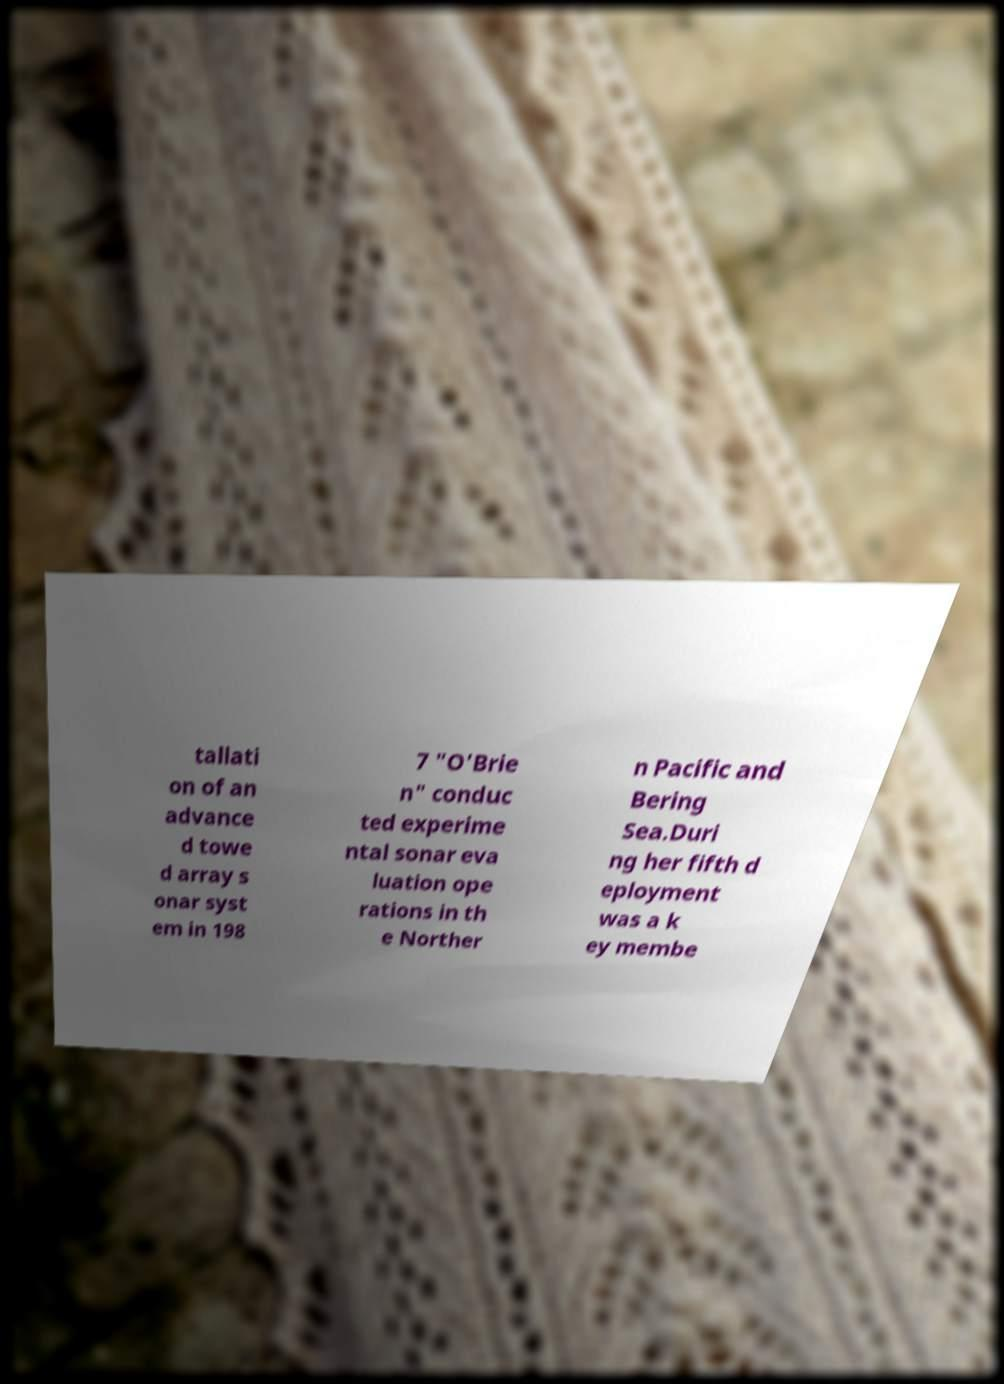Can you accurately transcribe the text from the provided image for me? tallati on of an advance d towe d array s onar syst em in 198 7 "O'Brie n" conduc ted experime ntal sonar eva luation ope rations in th e Norther n Pacific and Bering Sea.Duri ng her fifth d eployment was a k ey membe 